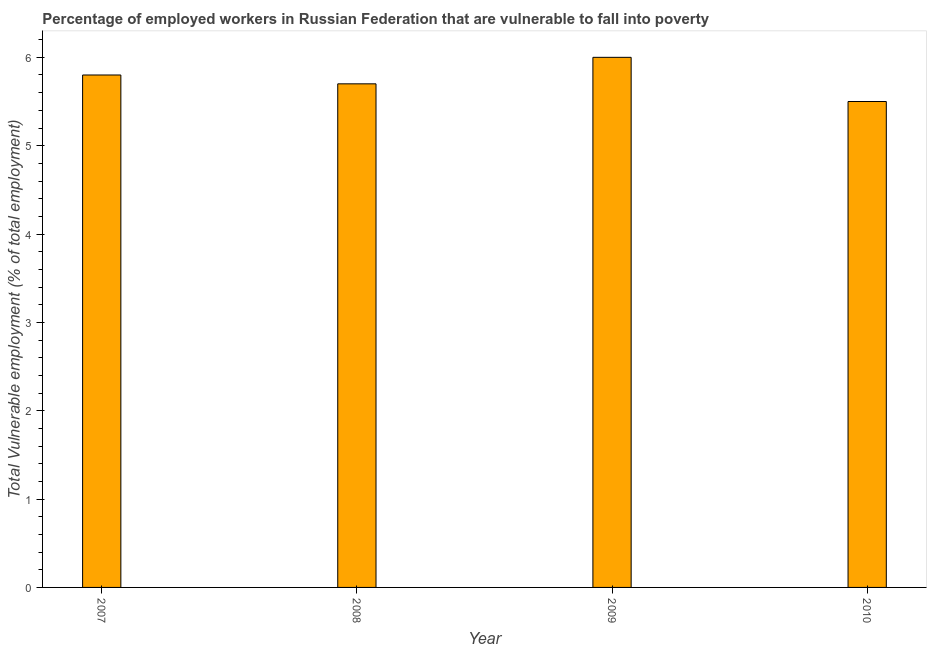Does the graph contain any zero values?
Offer a terse response. No. Does the graph contain grids?
Give a very brief answer. No. What is the title of the graph?
Offer a very short reply. Percentage of employed workers in Russian Federation that are vulnerable to fall into poverty. What is the label or title of the X-axis?
Offer a terse response. Year. What is the label or title of the Y-axis?
Ensure brevity in your answer.  Total Vulnerable employment (% of total employment). What is the total vulnerable employment in 2008?
Your answer should be very brief. 5.7. Across all years, what is the minimum total vulnerable employment?
Your answer should be compact. 5.5. In which year was the total vulnerable employment minimum?
Your answer should be compact. 2010. What is the average total vulnerable employment per year?
Make the answer very short. 5.75. What is the median total vulnerable employment?
Ensure brevity in your answer.  5.75. In how many years, is the total vulnerable employment greater than 1.2 %?
Provide a short and direct response. 4. Do a majority of the years between 2008 and 2007 (inclusive) have total vulnerable employment greater than 1.4 %?
Provide a succinct answer. No. What is the ratio of the total vulnerable employment in 2007 to that in 2010?
Offer a terse response. 1.05. Is the total vulnerable employment in 2008 less than that in 2009?
Offer a terse response. Yes. What is the difference between the highest and the second highest total vulnerable employment?
Keep it short and to the point. 0.2. What is the difference between the highest and the lowest total vulnerable employment?
Your response must be concise. 0.5. How many bars are there?
Keep it short and to the point. 4. Are all the bars in the graph horizontal?
Offer a very short reply. No. What is the difference between two consecutive major ticks on the Y-axis?
Give a very brief answer. 1. Are the values on the major ticks of Y-axis written in scientific E-notation?
Ensure brevity in your answer.  No. What is the Total Vulnerable employment (% of total employment) in 2007?
Offer a terse response. 5.8. What is the Total Vulnerable employment (% of total employment) of 2008?
Offer a terse response. 5.7. What is the Total Vulnerable employment (% of total employment) in 2010?
Provide a short and direct response. 5.5. What is the difference between the Total Vulnerable employment (% of total employment) in 2007 and 2009?
Keep it short and to the point. -0.2. What is the difference between the Total Vulnerable employment (% of total employment) in 2008 and 2010?
Give a very brief answer. 0.2. What is the difference between the Total Vulnerable employment (% of total employment) in 2009 and 2010?
Offer a terse response. 0.5. What is the ratio of the Total Vulnerable employment (% of total employment) in 2007 to that in 2009?
Ensure brevity in your answer.  0.97. What is the ratio of the Total Vulnerable employment (% of total employment) in 2007 to that in 2010?
Offer a terse response. 1.05. What is the ratio of the Total Vulnerable employment (% of total employment) in 2008 to that in 2010?
Offer a very short reply. 1.04. What is the ratio of the Total Vulnerable employment (% of total employment) in 2009 to that in 2010?
Offer a very short reply. 1.09. 